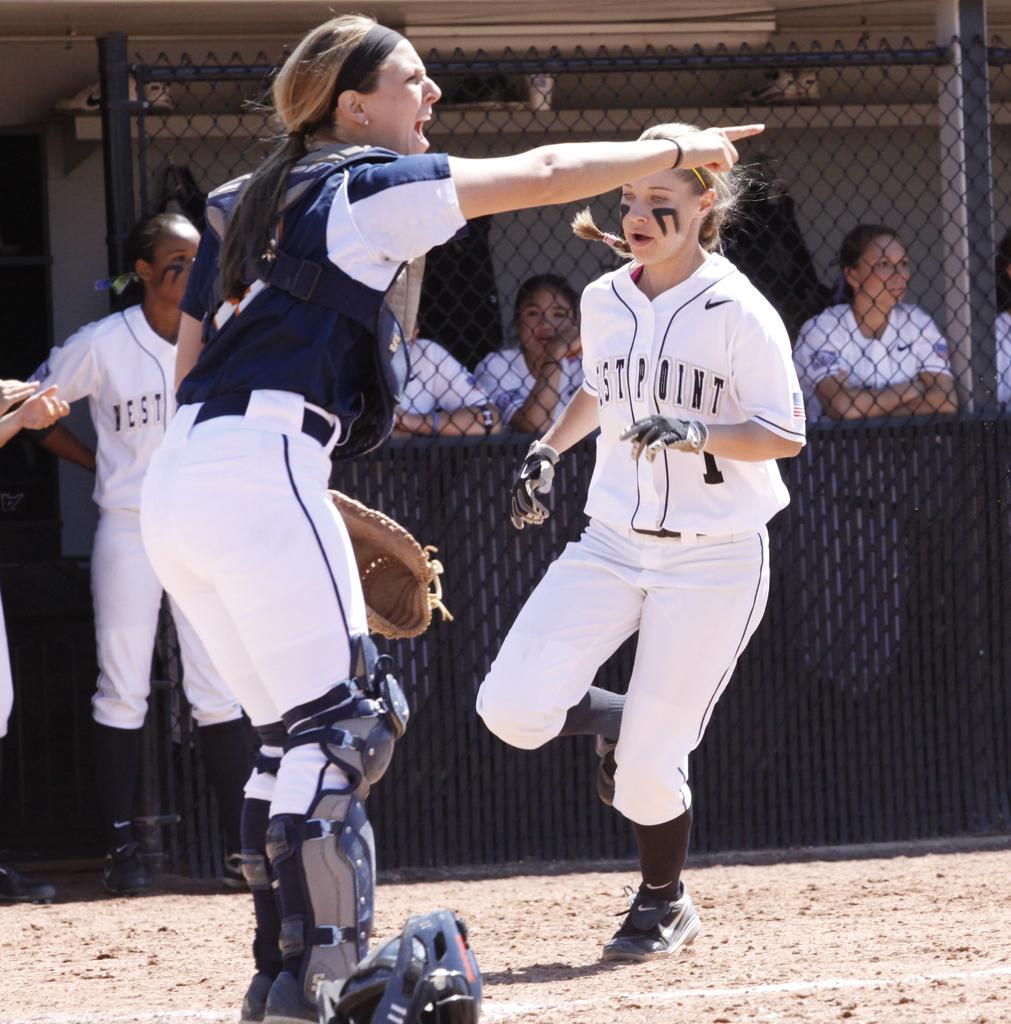<image>
Render a clear and concise summary of the photo. A lady umpire pointing in a direction while a player with west point on her shirt runs. 